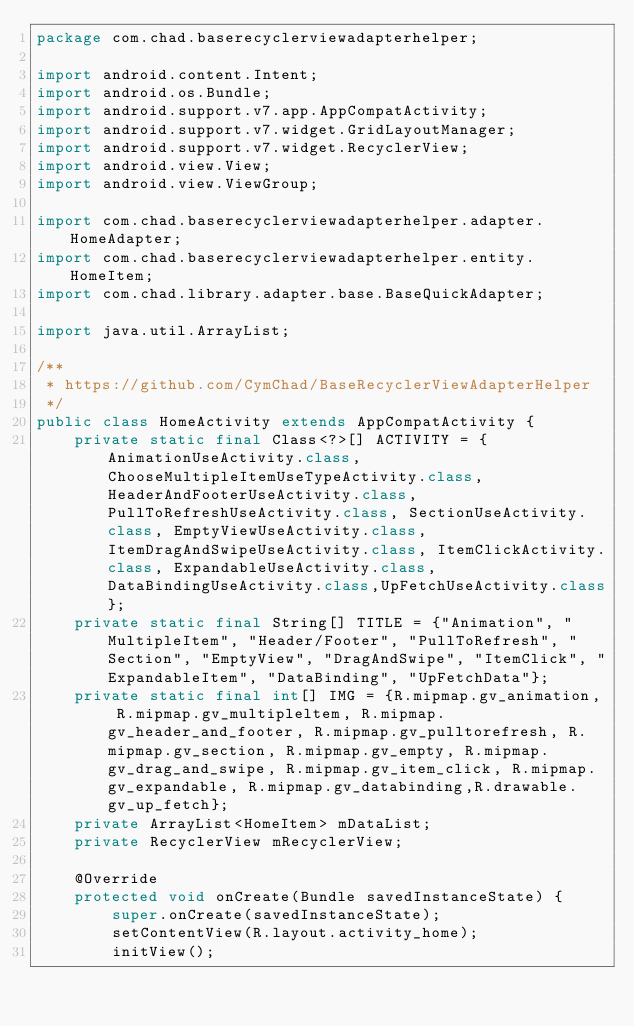Convert code to text. <code><loc_0><loc_0><loc_500><loc_500><_Java_>package com.chad.baserecyclerviewadapterhelper;

import android.content.Intent;
import android.os.Bundle;
import android.support.v7.app.AppCompatActivity;
import android.support.v7.widget.GridLayoutManager;
import android.support.v7.widget.RecyclerView;
import android.view.View;
import android.view.ViewGroup;

import com.chad.baserecyclerviewadapterhelper.adapter.HomeAdapter;
import com.chad.baserecyclerviewadapterhelper.entity.HomeItem;
import com.chad.library.adapter.base.BaseQuickAdapter;

import java.util.ArrayList;

/**
 * https://github.com/CymChad/BaseRecyclerViewAdapterHelper
 */
public class HomeActivity extends AppCompatActivity {
    private static final Class<?>[] ACTIVITY = {AnimationUseActivity.class, ChooseMultipleItemUseTypeActivity.class, HeaderAndFooterUseActivity.class, PullToRefreshUseActivity.class, SectionUseActivity.class, EmptyViewUseActivity.class, ItemDragAndSwipeUseActivity.class, ItemClickActivity.class, ExpandableUseActivity.class, DataBindingUseActivity.class,UpFetchUseActivity.class};
    private static final String[] TITLE = {"Animation", "MultipleItem", "Header/Footer", "PullToRefresh", "Section", "EmptyView", "DragAndSwipe", "ItemClick", "ExpandableItem", "DataBinding", "UpFetchData"};
    private static final int[] IMG = {R.mipmap.gv_animation, R.mipmap.gv_multipleltem, R.mipmap.gv_header_and_footer, R.mipmap.gv_pulltorefresh, R.mipmap.gv_section, R.mipmap.gv_empty, R.mipmap.gv_drag_and_swipe, R.mipmap.gv_item_click, R.mipmap.gv_expandable, R.mipmap.gv_databinding,R.drawable.gv_up_fetch};
    private ArrayList<HomeItem> mDataList;
    private RecyclerView mRecyclerView;

    @Override
    protected void onCreate(Bundle savedInstanceState) {
        super.onCreate(savedInstanceState);
        setContentView(R.layout.activity_home);
        initView();</code> 